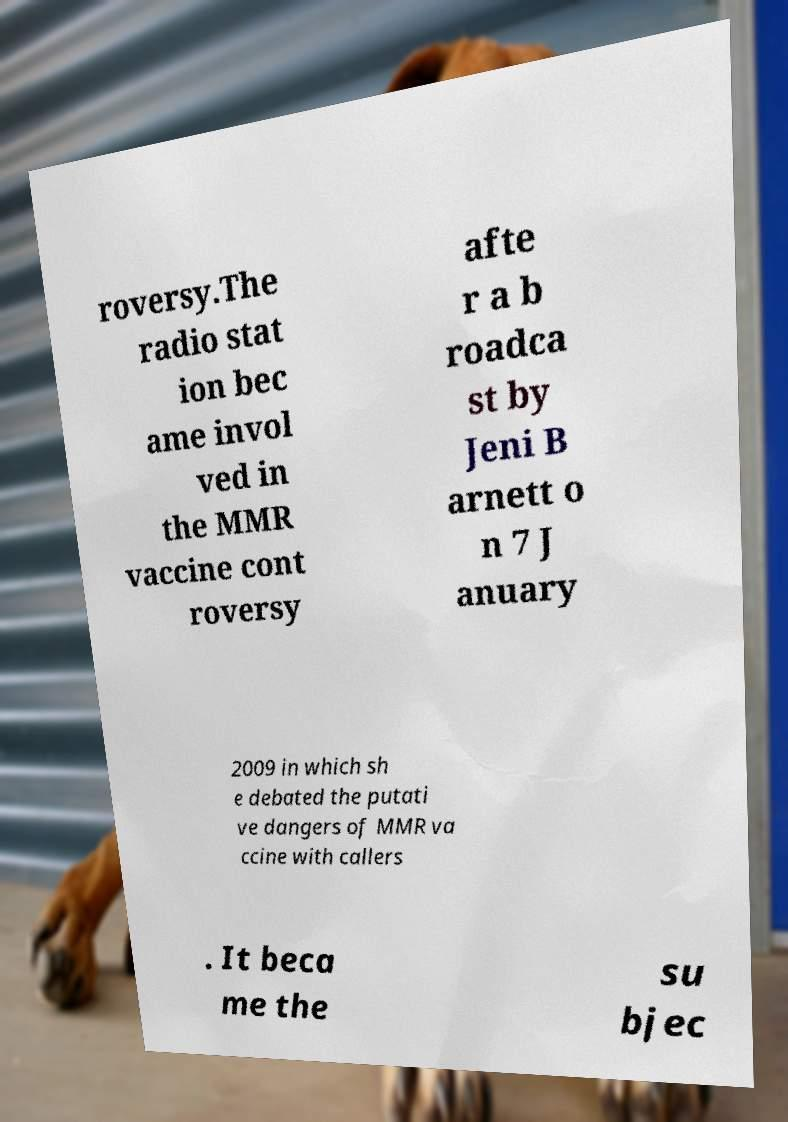Can you accurately transcribe the text from the provided image for me? roversy.The radio stat ion bec ame invol ved in the MMR vaccine cont roversy afte r a b roadca st by Jeni B arnett o n 7 J anuary 2009 in which sh e debated the putati ve dangers of MMR va ccine with callers . It beca me the su bjec 